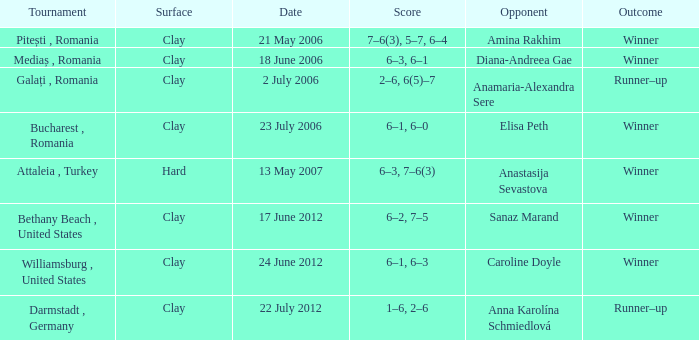What tournament was held on 21 May 2006? Pitești , Romania. 